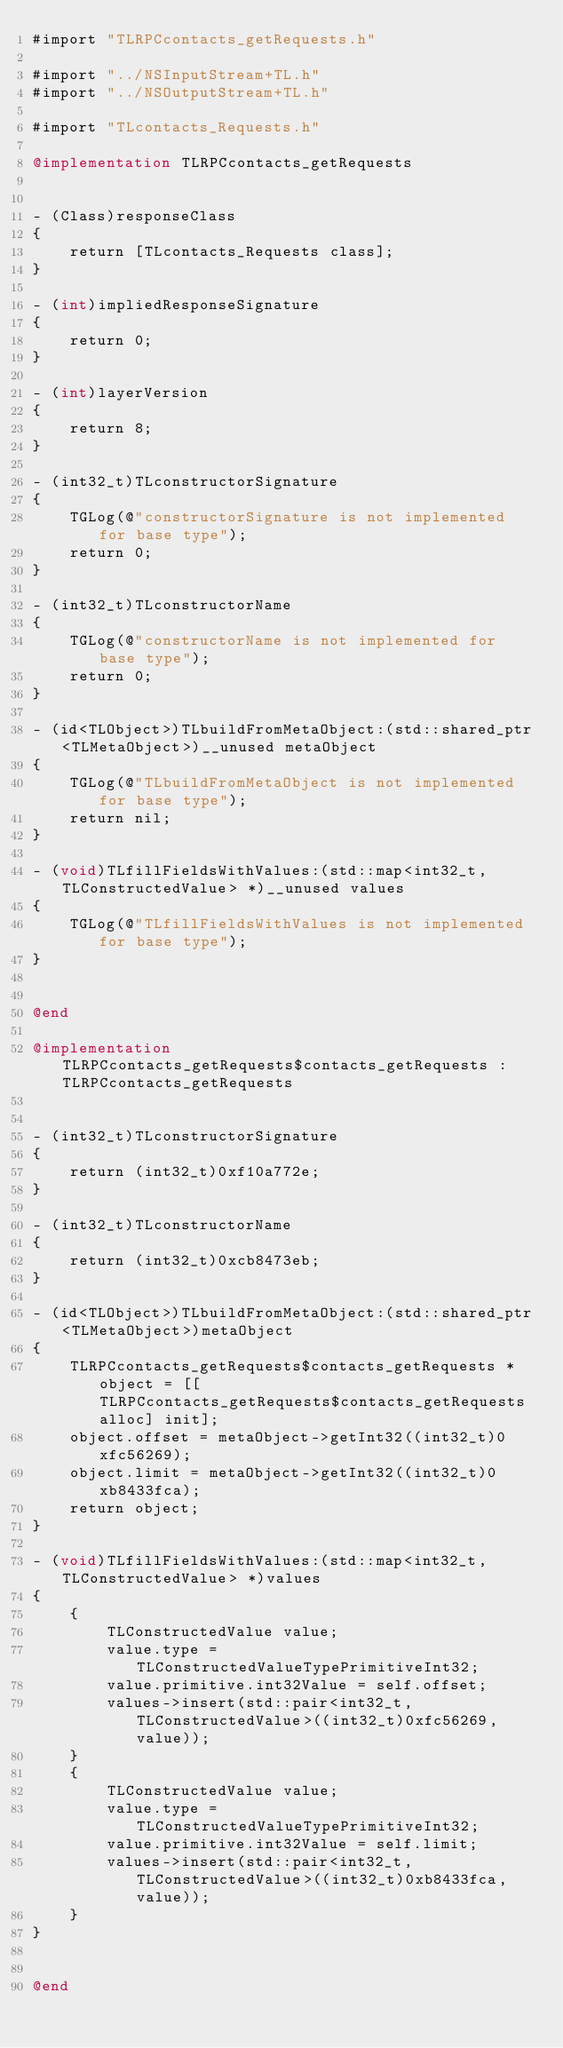<code> <loc_0><loc_0><loc_500><loc_500><_ObjectiveC_>#import "TLRPCcontacts_getRequests.h"

#import "../NSInputStream+TL.h"
#import "../NSOutputStream+TL.h"

#import "TLcontacts_Requests.h"

@implementation TLRPCcontacts_getRequests


- (Class)responseClass
{
    return [TLcontacts_Requests class];
}

- (int)impliedResponseSignature
{
    return 0;
}

- (int)layerVersion
{
    return 8;
}

- (int32_t)TLconstructorSignature
{
    TGLog(@"constructorSignature is not implemented for base type");
    return 0;
}

- (int32_t)TLconstructorName
{
    TGLog(@"constructorName is not implemented for base type");
    return 0;
}

- (id<TLObject>)TLbuildFromMetaObject:(std::shared_ptr<TLMetaObject>)__unused metaObject
{
    TGLog(@"TLbuildFromMetaObject is not implemented for base type");
    return nil;
}

- (void)TLfillFieldsWithValues:(std::map<int32_t, TLConstructedValue> *)__unused values
{
    TGLog(@"TLfillFieldsWithValues is not implemented for base type");
}


@end

@implementation TLRPCcontacts_getRequests$contacts_getRequests : TLRPCcontacts_getRequests


- (int32_t)TLconstructorSignature
{
    return (int32_t)0xf10a772e;
}

- (int32_t)TLconstructorName
{
    return (int32_t)0xcb8473eb;
}

- (id<TLObject>)TLbuildFromMetaObject:(std::shared_ptr<TLMetaObject>)metaObject
{
    TLRPCcontacts_getRequests$contacts_getRequests *object = [[TLRPCcontacts_getRequests$contacts_getRequests alloc] init];
    object.offset = metaObject->getInt32((int32_t)0xfc56269);
    object.limit = metaObject->getInt32((int32_t)0xb8433fca);
    return object;
}

- (void)TLfillFieldsWithValues:(std::map<int32_t, TLConstructedValue> *)values
{
    {
        TLConstructedValue value;
        value.type = TLConstructedValueTypePrimitiveInt32;
        value.primitive.int32Value = self.offset;
        values->insert(std::pair<int32_t, TLConstructedValue>((int32_t)0xfc56269, value));
    }
    {
        TLConstructedValue value;
        value.type = TLConstructedValueTypePrimitiveInt32;
        value.primitive.int32Value = self.limit;
        values->insert(std::pair<int32_t, TLConstructedValue>((int32_t)0xb8433fca, value));
    }
}


@end

</code> 